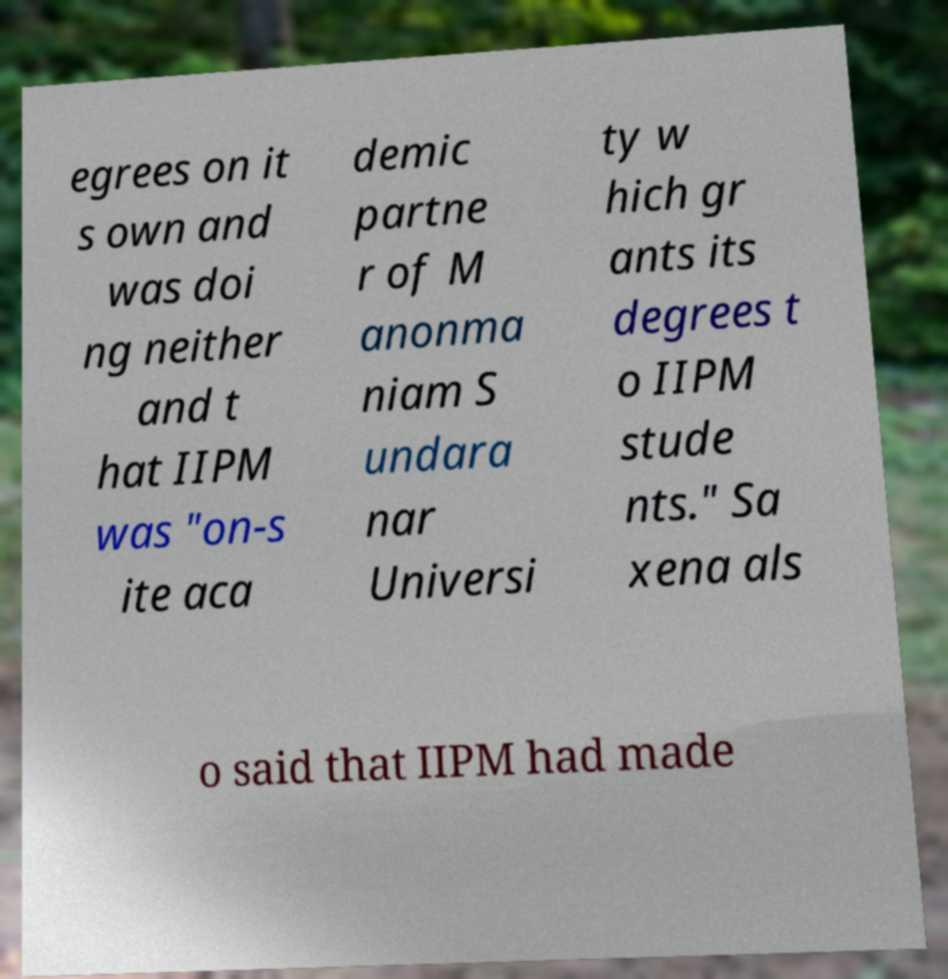Please identify and transcribe the text found in this image. egrees on it s own and was doi ng neither and t hat IIPM was "on-s ite aca demic partne r of M anonma niam S undara nar Universi ty w hich gr ants its degrees t o IIPM stude nts." Sa xena als o said that IIPM had made 